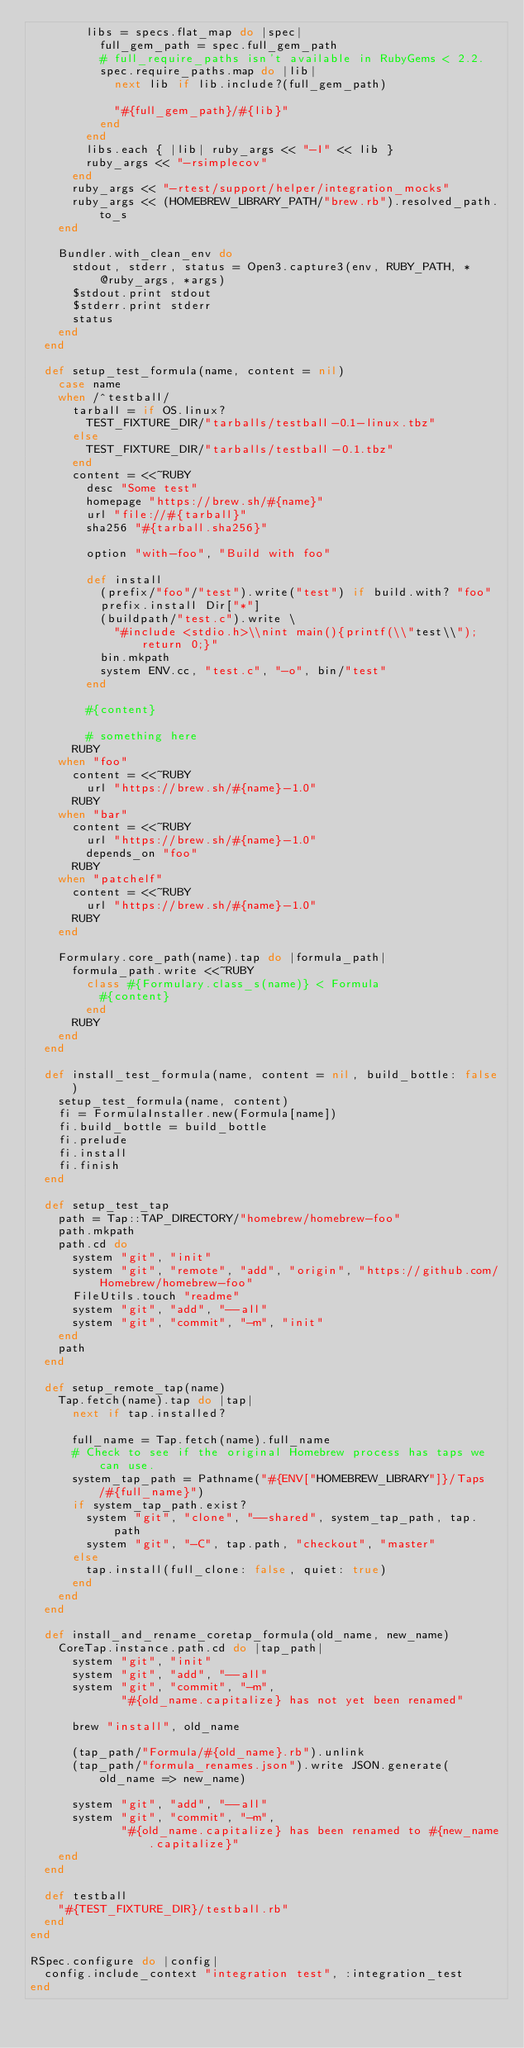<code> <loc_0><loc_0><loc_500><loc_500><_Ruby_>        libs = specs.flat_map do |spec|
          full_gem_path = spec.full_gem_path
          # full_require_paths isn't available in RubyGems < 2.2.
          spec.require_paths.map do |lib|
            next lib if lib.include?(full_gem_path)

            "#{full_gem_path}/#{lib}"
          end
        end
        libs.each { |lib| ruby_args << "-I" << lib }
        ruby_args << "-rsimplecov"
      end
      ruby_args << "-rtest/support/helper/integration_mocks"
      ruby_args << (HOMEBREW_LIBRARY_PATH/"brew.rb").resolved_path.to_s
    end

    Bundler.with_clean_env do
      stdout, stderr, status = Open3.capture3(env, RUBY_PATH, *@ruby_args, *args)
      $stdout.print stdout
      $stderr.print stderr
      status
    end
  end

  def setup_test_formula(name, content = nil)
    case name
    when /^testball/
      tarball = if OS.linux?
        TEST_FIXTURE_DIR/"tarballs/testball-0.1-linux.tbz"
      else
        TEST_FIXTURE_DIR/"tarballs/testball-0.1.tbz"
      end
      content = <<~RUBY
        desc "Some test"
        homepage "https://brew.sh/#{name}"
        url "file://#{tarball}"
        sha256 "#{tarball.sha256}"

        option "with-foo", "Build with foo"

        def install
          (prefix/"foo"/"test").write("test") if build.with? "foo"
          prefix.install Dir["*"]
          (buildpath/"test.c").write \
            "#include <stdio.h>\\nint main(){printf(\\"test\\");return 0;}"
          bin.mkpath
          system ENV.cc, "test.c", "-o", bin/"test"
        end

        #{content}

        # something here
      RUBY
    when "foo"
      content = <<~RUBY
        url "https://brew.sh/#{name}-1.0"
      RUBY
    when "bar"
      content = <<~RUBY
        url "https://brew.sh/#{name}-1.0"
        depends_on "foo"
      RUBY
    when "patchelf"
      content = <<~RUBY
        url "https://brew.sh/#{name}-1.0"
      RUBY
    end

    Formulary.core_path(name).tap do |formula_path|
      formula_path.write <<~RUBY
        class #{Formulary.class_s(name)} < Formula
          #{content}
        end
      RUBY
    end
  end

  def install_test_formula(name, content = nil, build_bottle: false)
    setup_test_formula(name, content)
    fi = FormulaInstaller.new(Formula[name])
    fi.build_bottle = build_bottle
    fi.prelude
    fi.install
    fi.finish
  end

  def setup_test_tap
    path = Tap::TAP_DIRECTORY/"homebrew/homebrew-foo"
    path.mkpath
    path.cd do
      system "git", "init"
      system "git", "remote", "add", "origin", "https://github.com/Homebrew/homebrew-foo"
      FileUtils.touch "readme"
      system "git", "add", "--all"
      system "git", "commit", "-m", "init"
    end
    path
  end

  def setup_remote_tap(name)
    Tap.fetch(name).tap do |tap|
      next if tap.installed?

      full_name = Tap.fetch(name).full_name
      # Check to see if the original Homebrew process has taps we can use.
      system_tap_path = Pathname("#{ENV["HOMEBREW_LIBRARY"]}/Taps/#{full_name}")
      if system_tap_path.exist?
        system "git", "clone", "--shared", system_tap_path, tap.path
        system "git", "-C", tap.path, "checkout", "master"
      else
        tap.install(full_clone: false, quiet: true)
      end
    end
  end

  def install_and_rename_coretap_formula(old_name, new_name)
    CoreTap.instance.path.cd do |tap_path|
      system "git", "init"
      system "git", "add", "--all"
      system "git", "commit", "-m",
             "#{old_name.capitalize} has not yet been renamed"

      brew "install", old_name

      (tap_path/"Formula/#{old_name}.rb").unlink
      (tap_path/"formula_renames.json").write JSON.generate(old_name => new_name)

      system "git", "add", "--all"
      system "git", "commit", "-m",
             "#{old_name.capitalize} has been renamed to #{new_name.capitalize}"
    end
  end

  def testball
    "#{TEST_FIXTURE_DIR}/testball.rb"
  end
end

RSpec.configure do |config|
  config.include_context "integration test", :integration_test
end
</code> 